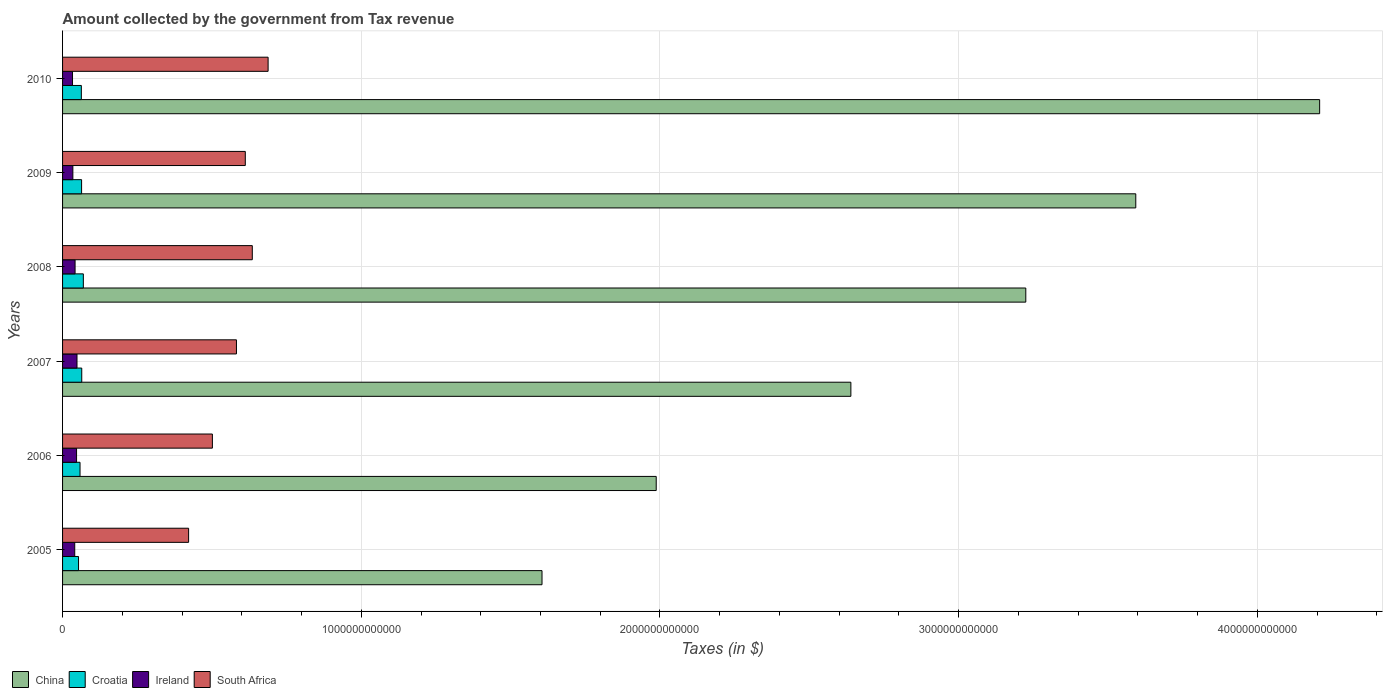Are the number of bars on each tick of the Y-axis equal?
Provide a succinct answer. Yes. What is the amount collected by the government from tax revenue in Ireland in 2010?
Offer a terse response. 3.33e+1. Across all years, what is the maximum amount collected by the government from tax revenue in South Africa?
Provide a succinct answer. 6.88e+11. Across all years, what is the minimum amount collected by the government from tax revenue in Ireland?
Your answer should be compact. 3.33e+1. In which year was the amount collected by the government from tax revenue in South Africa minimum?
Offer a terse response. 2005. What is the total amount collected by the government from tax revenue in China in the graph?
Offer a terse response. 1.73e+13. What is the difference between the amount collected by the government from tax revenue in South Africa in 2005 and that in 2010?
Provide a short and direct response. -2.66e+11. What is the difference between the amount collected by the government from tax revenue in China in 2009 and the amount collected by the government from tax revenue in Ireland in 2007?
Your answer should be very brief. 3.54e+12. What is the average amount collected by the government from tax revenue in China per year?
Keep it short and to the point. 2.88e+12. In the year 2005, what is the difference between the amount collected by the government from tax revenue in China and amount collected by the government from tax revenue in South Africa?
Your response must be concise. 1.18e+12. In how many years, is the amount collected by the government from tax revenue in South Africa greater than 4000000000000 $?
Ensure brevity in your answer.  0. What is the ratio of the amount collected by the government from tax revenue in Croatia in 2006 to that in 2010?
Your answer should be very brief. 0.93. Is the difference between the amount collected by the government from tax revenue in China in 2006 and 2008 greater than the difference between the amount collected by the government from tax revenue in South Africa in 2006 and 2008?
Provide a succinct answer. No. What is the difference between the highest and the second highest amount collected by the government from tax revenue in China?
Provide a short and direct response. 6.16e+11. What is the difference between the highest and the lowest amount collected by the government from tax revenue in Croatia?
Offer a terse response. 1.61e+1. In how many years, is the amount collected by the government from tax revenue in South Africa greater than the average amount collected by the government from tax revenue in South Africa taken over all years?
Provide a succinct answer. 4. Is the sum of the amount collected by the government from tax revenue in South Africa in 2008 and 2010 greater than the maximum amount collected by the government from tax revenue in China across all years?
Give a very brief answer. No. What does the 3rd bar from the bottom in 2007 represents?
Offer a very short reply. Ireland. How many bars are there?
Give a very brief answer. 24. What is the difference between two consecutive major ticks on the X-axis?
Keep it short and to the point. 1.00e+12. Does the graph contain any zero values?
Provide a succinct answer. No. Does the graph contain grids?
Your answer should be compact. Yes. Where does the legend appear in the graph?
Ensure brevity in your answer.  Bottom left. How many legend labels are there?
Your response must be concise. 4. How are the legend labels stacked?
Your answer should be compact. Horizontal. What is the title of the graph?
Your response must be concise. Amount collected by the government from Tax revenue. What is the label or title of the X-axis?
Your answer should be very brief. Taxes (in $). What is the label or title of the Y-axis?
Give a very brief answer. Years. What is the Taxes (in $) in China in 2005?
Offer a very short reply. 1.61e+12. What is the Taxes (in $) of Croatia in 2005?
Provide a short and direct response. 5.34e+1. What is the Taxes (in $) in Ireland in 2005?
Offer a terse response. 4.07e+1. What is the Taxes (in $) of South Africa in 2005?
Your answer should be compact. 4.22e+11. What is the Taxes (in $) of China in 2006?
Make the answer very short. 1.99e+12. What is the Taxes (in $) of Croatia in 2006?
Your response must be concise. 5.85e+1. What is the Taxes (in $) of Ireland in 2006?
Ensure brevity in your answer.  4.69e+1. What is the Taxes (in $) of South Africa in 2006?
Ensure brevity in your answer.  5.02e+11. What is the Taxes (in $) in China in 2007?
Provide a succinct answer. 2.64e+12. What is the Taxes (in $) of Croatia in 2007?
Your response must be concise. 6.42e+1. What is the Taxes (in $) in Ireland in 2007?
Offer a very short reply. 4.83e+1. What is the Taxes (in $) in South Africa in 2007?
Your answer should be very brief. 5.82e+11. What is the Taxes (in $) in China in 2008?
Offer a very short reply. 3.22e+12. What is the Taxes (in $) in Croatia in 2008?
Make the answer very short. 6.96e+1. What is the Taxes (in $) in Ireland in 2008?
Your answer should be very brief. 4.19e+1. What is the Taxes (in $) in South Africa in 2008?
Your answer should be very brief. 6.35e+11. What is the Taxes (in $) of China in 2009?
Your response must be concise. 3.59e+12. What is the Taxes (in $) of Croatia in 2009?
Your response must be concise. 6.37e+1. What is the Taxes (in $) in Ireland in 2009?
Offer a terse response. 3.45e+1. What is the Taxes (in $) in South Africa in 2009?
Provide a succinct answer. 6.12e+11. What is the Taxes (in $) in China in 2010?
Your response must be concise. 4.21e+12. What is the Taxes (in $) of Croatia in 2010?
Offer a very short reply. 6.29e+1. What is the Taxes (in $) of Ireland in 2010?
Your answer should be very brief. 3.33e+1. What is the Taxes (in $) in South Africa in 2010?
Your answer should be very brief. 6.88e+11. Across all years, what is the maximum Taxes (in $) of China?
Ensure brevity in your answer.  4.21e+12. Across all years, what is the maximum Taxes (in $) of Croatia?
Give a very brief answer. 6.96e+1. Across all years, what is the maximum Taxes (in $) in Ireland?
Provide a short and direct response. 4.83e+1. Across all years, what is the maximum Taxes (in $) of South Africa?
Keep it short and to the point. 6.88e+11. Across all years, what is the minimum Taxes (in $) in China?
Keep it short and to the point. 1.61e+12. Across all years, what is the minimum Taxes (in $) in Croatia?
Offer a terse response. 5.34e+1. Across all years, what is the minimum Taxes (in $) in Ireland?
Provide a short and direct response. 3.33e+1. Across all years, what is the minimum Taxes (in $) of South Africa?
Your answer should be compact. 4.22e+11. What is the total Taxes (in $) in China in the graph?
Your response must be concise. 1.73e+13. What is the total Taxes (in $) in Croatia in the graph?
Offer a terse response. 3.72e+11. What is the total Taxes (in $) in Ireland in the graph?
Offer a very short reply. 2.46e+11. What is the total Taxes (in $) in South Africa in the graph?
Give a very brief answer. 3.44e+12. What is the difference between the Taxes (in $) in China in 2005 and that in 2006?
Keep it short and to the point. -3.82e+11. What is the difference between the Taxes (in $) in Croatia in 2005 and that in 2006?
Make the answer very short. -5.02e+09. What is the difference between the Taxes (in $) in Ireland in 2005 and that in 2006?
Give a very brief answer. -6.11e+09. What is the difference between the Taxes (in $) in South Africa in 2005 and that in 2006?
Keep it short and to the point. -7.96e+1. What is the difference between the Taxes (in $) in China in 2005 and that in 2007?
Your answer should be compact. -1.03e+12. What is the difference between the Taxes (in $) of Croatia in 2005 and that in 2007?
Your answer should be compact. -1.08e+1. What is the difference between the Taxes (in $) of Ireland in 2005 and that in 2007?
Provide a short and direct response. -7.58e+09. What is the difference between the Taxes (in $) in South Africa in 2005 and that in 2007?
Your response must be concise. -1.60e+11. What is the difference between the Taxes (in $) of China in 2005 and that in 2008?
Ensure brevity in your answer.  -1.62e+12. What is the difference between the Taxes (in $) of Croatia in 2005 and that in 2008?
Make the answer very short. -1.61e+1. What is the difference between the Taxes (in $) of Ireland in 2005 and that in 2008?
Make the answer very short. -1.15e+09. What is the difference between the Taxes (in $) in South Africa in 2005 and that in 2008?
Offer a very short reply. -2.13e+11. What is the difference between the Taxes (in $) of China in 2005 and that in 2009?
Provide a short and direct response. -1.99e+12. What is the difference between the Taxes (in $) of Croatia in 2005 and that in 2009?
Give a very brief answer. -1.02e+1. What is the difference between the Taxes (in $) of Ireland in 2005 and that in 2009?
Make the answer very short. 6.29e+09. What is the difference between the Taxes (in $) of South Africa in 2005 and that in 2009?
Your response must be concise. -1.90e+11. What is the difference between the Taxes (in $) in China in 2005 and that in 2010?
Ensure brevity in your answer.  -2.60e+12. What is the difference between the Taxes (in $) of Croatia in 2005 and that in 2010?
Keep it short and to the point. -9.41e+09. What is the difference between the Taxes (in $) of Ireland in 2005 and that in 2010?
Offer a terse response. 7.42e+09. What is the difference between the Taxes (in $) of South Africa in 2005 and that in 2010?
Make the answer very short. -2.66e+11. What is the difference between the Taxes (in $) in China in 2006 and that in 2007?
Offer a very short reply. -6.52e+11. What is the difference between the Taxes (in $) of Croatia in 2006 and that in 2007?
Your answer should be compact. -5.77e+09. What is the difference between the Taxes (in $) of Ireland in 2006 and that in 2007?
Your answer should be very brief. -1.47e+09. What is the difference between the Taxes (in $) in South Africa in 2006 and that in 2007?
Ensure brevity in your answer.  -8.05e+1. What is the difference between the Taxes (in $) of China in 2006 and that in 2008?
Ensure brevity in your answer.  -1.24e+12. What is the difference between the Taxes (in $) of Croatia in 2006 and that in 2008?
Provide a short and direct response. -1.11e+1. What is the difference between the Taxes (in $) of Ireland in 2006 and that in 2008?
Your response must be concise. 4.96e+09. What is the difference between the Taxes (in $) in South Africa in 2006 and that in 2008?
Your response must be concise. -1.34e+11. What is the difference between the Taxes (in $) of China in 2006 and that in 2009?
Make the answer very short. -1.61e+12. What is the difference between the Taxes (in $) in Croatia in 2006 and that in 2009?
Provide a succinct answer. -5.21e+09. What is the difference between the Taxes (in $) in Ireland in 2006 and that in 2009?
Give a very brief answer. 1.24e+1. What is the difference between the Taxes (in $) in South Africa in 2006 and that in 2009?
Make the answer very short. -1.10e+11. What is the difference between the Taxes (in $) in China in 2006 and that in 2010?
Give a very brief answer. -2.22e+12. What is the difference between the Taxes (in $) in Croatia in 2006 and that in 2010?
Your response must be concise. -4.39e+09. What is the difference between the Taxes (in $) in Ireland in 2006 and that in 2010?
Provide a succinct answer. 1.35e+1. What is the difference between the Taxes (in $) of South Africa in 2006 and that in 2010?
Your response must be concise. -1.87e+11. What is the difference between the Taxes (in $) in China in 2007 and that in 2008?
Provide a succinct answer. -5.86e+11. What is the difference between the Taxes (in $) in Croatia in 2007 and that in 2008?
Your answer should be very brief. -5.34e+09. What is the difference between the Taxes (in $) of Ireland in 2007 and that in 2008?
Your answer should be very brief. 6.43e+09. What is the difference between the Taxes (in $) in South Africa in 2007 and that in 2008?
Keep it short and to the point. -5.31e+1. What is the difference between the Taxes (in $) in China in 2007 and that in 2009?
Your response must be concise. -9.54e+11. What is the difference between the Taxes (in $) in Croatia in 2007 and that in 2009?
Provide a succinct answer. 5.56e+08. What is the difference between the Taxes (in $) in Ireland in 2007 and that in 2009?
Give a very brief answer. 1.39e+1. What is the difference between the Taxes (in $) in South Africa in 2007 and that in 2009?
Offer a terse response. -2.97e+1. What is the difference between the Taxes (in $) in China in 2007 and that in 2010?
Give a very brief answer. -1.57e+12. What is the difference between the Taxes (in $) of Croatia in 2007 and that in 2010?
Provide a short and direct response. 1.38e+09. What is the difference between the Taxes (in $) in Ireland in 2007 and that in 2010?
Keep it short and to the point. 1.50e+1. What is the difference between the Taxes (in $) of South Africa in 2007 and that in 2010?
Give a very brief answer. -1.06e+11. What is the difference between the Taxes (in $) of China in 2008 and that in 2009?
Provide a short and direct response. -3.68e+11. What is the difference between the Taxes (in $) of Croatia in 2008 and that in 2009?
Keep it short and to the point. 5.89e+09. What is the difference between the Taxes (in $) in Ireland in 2008 and that in 2009?
Your answer should be compact. 7.44e+09. What is the difference between the Taxes (in $) in South Africa in 2008 and that in 2009?
Give a very brief answer. 2.34e+1. What is the difference between the Taxes (in $) of China in 2008 and that in 2010?
Offer a terse response. -9.84e+11. What is the difference between the Taxes (in $) in Croatia in 2008 and that in 2010?
Your answer should be compact. 6.72e+09. What is the difference between the Taxes (in $) of Ireland in 2008 and that in 2010?
Your answer should be compact. 8.56e+09. What is the difference between the Taxes (in $) of South Africa in 2008 and that in 2010?
Ensure brevity in your answer.  -5.29e+1. What is the difference between the Taxes (in $) in China in 2009 and that in 2010?
Give a very brief answer. -6.16e+11. What is the difference between the Taxes (in $) of Croatia in 2009 and that in 2010?
Provide a succinct answer. 8.22e+08. What is the difference between the Taxes (in $) in Ireland in 2009 and that in 2010?
Make the answer very short. 1.13e+09. What is the difference between the Taxes (in $) in South Africa in 2009 and that in 2010?
Ensure brevity in your answer.  -7.63e+1. What is the difference between the Taxes (in $) of China in 2005 and the Taxes (in $) of Croatia in 2006?
Your answer should be compact. 1.55e+12. What is the difference between the Taxes (in $) of China in 2005 and the Taxes (in $) of Ireland in 2006?
Your answer should be very brief. 1.56e+12. What is the difference between the Taxes (in $) in China in 2005 and the Taxes (in $) in South Africa in 2006?
Give a very brief answer. 1.10e+12. What is the difference between the Taxes (in $) of Croatia in 2005 and the Taxes (in $) of Ireland in 2006?
Provide a succinct answer. 6.60e+09. What is the difference between the Taxes (in $) in Croatia in 2005 and the Taxes (in $) in South Africa in 2006?
Provide a short and direct response. -4.48e+11. What is the difference between the Taxes (in $) of Ireland in 2005 and the Taxes (in $) of South Africa in 2006?
Your response must be concise. -4.61e+11. What is the difference between the Taxes (in $) in China in 2005 and the Taxes (in $) in Croatia in 2007?
Your response must be concise. 1.54e+12. What is the difference between the Taxes (in $) of China in 2005 and the Taxes (in $) of Ireland in 2007?
Provide a succinct answer. 1.56e+12. What is the difference between the Taxes (in $) of China in 2005 and the Taxes (in $) of South Africa in 2007?
Give a very brief answer. 1.02e+12. What is the difference between the Taxes (in $) of Croatia in 2005 and the Taxes (in $) of Ireland in 2007?
Give a very brief answer. 5.13e+09. What is the difference between the Taxes (in $) of Croatia in 2005 and the Taxes (in $) of South Africa in 2007?
Your response must be concise. -5.29e+11. What is the difference between the Taxes (in $) in Ireland in 2005 and the Taxes (in $) in South Africa in 2007?
Provide a succinct answer. -5.41e+11. What is the difference between the Taxes (in $) in China in 2005 and the Taxes (in $) in Croatia in 2008?
Keep it short and to the point. 1.54e+12. What is the difference between the Taxes (in $) in China in 2005 and the Taxes (in $) in Ireland in 2008?
Provide a succinct answer. 1.56e+12. What is the difference between the Taxes (in $) of China in 2005 and the Taxes (in $) of South Africa in 2008?
Give a very brief answer. 9.70e+11. What is the difference between the Taxes (in $) of Croatia in 2005 and the Taxes (in $) of Ireland in 2008?
Offer a terse response. 1.16e+1. What is the difference between the Taxes (in $) of Croatia in 2005 and the Taxes (in $) of South Africa in 2008?
Provide a short and direct response. -5.82e+11. What is the difference between the Taxes (in $) of Ireland in 2005 and the Taxes (in $) of South Africa in 2008?
Your answer should be very brief. -5.94e+11. What is the difference between the Taxes (in $) in China in 2005 and the Taxes (in $) in Croatia in 2009?
Your answer should be compact. 1.54e+12. What is the difference between the Taxes (in $) in China in 2005 and the Taxes (in $) in Ireland in 2009?
Keep it short and to the point. 1.57e+12. What is the difference between the Taxes (in $) in China in 2005 and the Taxes (in $) in South Africa in 2009?
Offer a terse response. 9.93e+11. What is the difference between the Taxes (in $) in Croatia in 2005 and the Taxes (in $) in Ireland in 2009?
Your answer should be very brief. 1.90e+1. What is the difference between the Taxes (in $) of Croatia in 2005 and the Taxes (in $) of South Africa in 2009?
Keep it short and to the point. -5.58e+11. What is the difference between the Taxes (in $) in Ireland in 2005 and the Taxes (in $) in South Africa in 2009?
Offer a very short reply. -5.71e+11. What is the difference between the Taxes (in $) in China in 2005 and the Taxes (in $) in Croatia in 2010?
Offer a very short reply. 1.54e+12. What is the difference between the Taxes (in $) in China in 2005 and the Taxes (in $) in Ireland in 2010?
Offer a very short reply. 1.57e+12. What is the difference between the Taxes (in $) in China in 2005 and the Taxes (in $) in South Africa in 2010?
Provide a short and direct response. 9.17e+11. What is the difference between the Taxes (in $) of Croatia in 2005 and the Taxes (in $) of Ireland in 2010?
Make the answer very short. 2.01e+1. What is the difference between the Taxes (in $) in Croatia in 2005 and the Taxes (in $) in South Africa in 2010?
Ensure brevity in your answer.  -6.35e+11. What is the difference between the Taxes (in $) of Ireland in 2005 and the Taxes (in $) of South Africa in 2010?
Give a very brief answer. -6.47e+11. What is the difference between the Taxes (in $) in China in 2006 and the Taxes (in $) in Croatia in 2007?
Your answer should be compact. 1.92e+12. What is the difference between the Taxes (in $) of China in 2006 and the Taxes (in $) of Ireland in 2007?
Provide a short and direct response. 1.94e+12. What is the difference between the Taxes (in $) in China in 2006 and the Taxes (in $) in South Africa in 2007?
Ensure brevity in your answer.  1.41e+12. What is the difference between the Taxes (in $) of Croatia in 2006 and the Taxes (in $) of Ireland in 2007?
Make the answer very short. 1.02e+1. What is the difference between the Taxes (in $) of Croatia in 2006 and the Taxes (in $) of South Africa in 2007?
Offer a very short reply. -5.24e+11. What is the difference between the Taxes (in $) in Ireland in 2006 and the Taxes (in $) in South Africa in 2007?
Make the answer very short. -5.35e+11. What is the difference between the Taxes (in $) of China in 2006 and the Taxes (in $) of Croatia in 2008?
Provide a short and direct response. 1.92e+12. What is the difference between the Taxes (in $) in China in 2006 and the Taxes (in $) in Ireland in 2008?
Offer a terse response. 1.95e+12. What is the difference between the Taxes (in $) in China in 2006 and the Taxes (in $) in South Africa in 2008?
Offer a terse response. 1.35e+12. What is the difference between the Taxes (in $) of Croatia in 2006 and the Taxes (in $) of Ireland in 2008?
Make the answer very short. 1.66e+1. What is the difference between the Taxes (in $) of Croatia in 2006 and the Taxes (in $) of South Africa in 2008?
Your answer should be compact. -5.77e+11. What is the difference between the Taxes (in $) of Ireland in 2006 and the Taxes (in $) of South Africa in 2008?
Keep it short and to the point. -5.88e+11. What is the difference between the Taxes (in $) of China in 2006 and the Taxes (in $) of Croatia in 2009?
Provide a short and direct response. 1.92e+12. What is the difference between the Taxes (in $) in China in 2006 and the Taxes (in $) in Ireland in 2009?
Provide a short and direct response. 1.95e+12. What is the difference between the Taxes (in $) of China in 2006 and the Taxes (in $) of South Africa in 2009?
Offer a terse response. 1.38e+12. What is the difference between the Taxes (in $) of Croatia in 2006 and the Taxes (in $) of Ireland in 2009?
Ensure brevity in your answer.  2.40e+1. What is the difference between the Taxes (in $) in Croatia in 2006 and the Taxes (in $) in South Africa in 2009?
Your answer should be compact. -5.53e+11. What is the difference between the Taxes (in $) of Ireland in 2006 and the Taxes (in $) of South Africa in 2009?
Offer a terse response. -5.65e+11. What is the difference between the Taxes (in $) of China in 2006 and the Taxes (in $) of Croatia in 2010?
Your answer should be compact. 1.92e+12. What is the difference between the Taxes (in $) in China in 2006 and the Taxes (in $) in Ireland in 2010?
Give a very brief answer. 1.95e+12. What is the difference between the Taxes (in $) of China in 2006 and the Taxes (in $) of South Africa in 2010?
Provide a short and direct response. 1.30e+12. What is the difference between the Taxes (in $) in Croatia in 2006 and the Taxes (in $) in Ireland in 2010?
Ensure brevity in your answer.  2.51e+1. What is the difference between the Taxes (in $) in Croatia in 2006 and the Taxes (in $) in South Africa in 2010?
Your answer should be very brief. -6.30e+11. What is the difference between the Taxes (in $) of Ireland in 2006 and the Taxes (in $) of South Africa in 2010?
Offer a terse response. -6.41e+11. What is the difference between the Taxes (in $) in China in 2007 and the Taxes (in $) in Croatia in 2008?
Your response must be concise. 2.57e+12. What is the difference between the Taxes (in $) of China in 2007 and the Taxes (in $) of Ireland in 2008?
Provide a succinct answer. 2.60e+12. What is the difference between the Taxes (in $) in China in 2007 and the Taxes (in $) in South Africa in 2008?
Offer a terse response. 2.00e+12. What is the difference between the Taxes (in $) in Croatia in 2007 and the Taxes (in $) in Ireland in 2008?
Your answer should be compact. 2.23e+1. What is the difference between the Taxes (in $) of Croatia in 2007 and the Taxes (in $) of South Africa in 2008?
Offer a terse response. -5.71e+11. What is the difference between the Taxes (in $) in Ireland in 2007 and the Taxes (in $) in South Africa in 2008?
Provide a short and direct response. -5.87e+11. What is the difference between the Taxes (in $) in China in 2007 and the Taxes (in $) in Croatia in 2009?
Keep it short and to the point. 2.58e+12. What is the difference between the Taxes (in $) in China in 2007 and the Taxes (in $) in Ireland in 2009?
Provide a short and direct response. 2.60e+12. What is the difference between the Taxes (in $) in China in 2007 and the Taxes (in $) in South Africa in 2009?
Your answer should be very brief. 2.03e+12. What is the difference between the Taxes (in $) in Croatia in 2007 and the Taxes (in $) in Ireland in 2009?
Keep it short and to the point. 2.98e+1. What is the difference between the Taxes (in $) in Croatia in 2007 and the Taxes (in $) in South Africa in 2009?
Keep it short and to the point. -5.48e+11. What is the difference between the Taxes (in $) of Ireland in 2007 and the Taxes (in $) of South Africa in 2009?
Give a very brief answer. -5.63e+11. What is the difference between the Taxes (in $) in China in 2007 and the Taxes (in $) in Croatia in 2010?
Offer a very short reply. 2.58e+12. What is the difference between the Taxes (in $) in China in 2007 and the Taxes (in $) in Ireland in 2010?
Your answer should be compact. 2.61e+12. What is the difference between the Taxes (in $) of China in 2007 and the Taxes (in $) of South Africa in 2010?
Offer a terse response. 1.95e+12. What is the difference between the Taxes (in $) of Croatia in 2007 and the Taxes (in $) of Ireland in 2010?
Offer a terse response. 3.09e+1. What is the difference between the Taxes (in $) in Croatia in 2007 and the Taxes (in $) in South Africa in 2010?
Ensure brevity in your answer.  -6.24e+11. What is the difference between the Taxes (in $) in Ireland in 2007 and the Taxes (in $) in South Africa in 2010?
Provide a short and direct response. -6.40e+11. What is the difference between the Taxes (in $) of China in 2008 and the Taxes (in $) of Croatia in 2009?
Your answer should be compact. 3.16e+12. What is the difference between the Taxes (in $) of China in 2008 and the Taxes (in $) of Ireland in 2009?
Your response must be concise. 3.19e+12. What is the difference between the Taxes (in $) of China in 2008 and the Taxes (in $) of South Africa in 2009?
Make the answer very short. 2.61e+12. What is the difference between the Taxes (in $) in Croatia in 2008 and the Taxes (in $) in Ireland in 2009?
Give a very brief answer. 3.51e+1. What is the difference between the Taxes (in $) in Croatia in 2008 and the Taxes (in $) in South Africa in 2009?
Provide a succinct answer. -5.42e+11. What is the difference between the Taxes (in $) of Ireland in 2008 and the Taxes (in $) of South Africa in 2009?
Ensure brevity in your answer.  -5.70e+11. What is the difference between the Taxes (in $) in China in 2008 and the Taxes (in $) in Croatia in 2010?
Ensure brevity in your answer.  3.16e+12. What is the difference between the Taxes (in $) in China in 2008 and the Taxes (in $) in Ireland in 2010?
Your response must be concise. 3.19e+12. What is the difference between the Taxes (in $) in China in 2008 and the Taxes (in $) in South Africa in 2010?
Your response must be concise. 2.54e+12. What is the difference between the Taxes (in $) of Croatia in 2008 and the Taxes (in $) of Ireland in 2010?
Provide a succinct answer. 3.62e+1. What is the difference between the Taxes (in $) in Croatia in 2008 and the Taxes (in $) in South Africa in 2010?
Provide a short and direct response. -6.19e+11. What is the difference between the Taxes (in $) of Ireland in 2008 and the Taxes (in $) of South Africa in 2010?
Provide a succinct answer. -6.46e+11. What is the difference between the Taxes (in $) of China in 2009 and the Taxes (in $) of Croatia in 2010?
Keep it short and to the point. 3.53e+12. What is the difference between the Taxes (in $) in China in 2009 and the Taxes (in $) in Ireland in 2010?
Your response must be concise. 3.56e+12. What is the difference between the Taxes (in $) in China in 2009 and the Taxes (in $) in South Africa in 2010?
Ensure brevity in your answer.  2.90e+12. What is the difference between the Taxes (in $) in Croatia in 2009 and the Taxes (in $) in Ireland in 2010?
Make the answer very short. 3.04e+1. What is the difference between the Taxes (in $) in Croatia in 2009 and the Taxes (in $) in South Africa in 2010?
Offer a very short reply. -6.24e+11. What is the difference between the Taxes (in $) in Ireland in 2009 and the Taxes (in $) in South Africa in 2010?
Your response must be concise. -6.54e+11. What is the average Taxes (in $) in China per year?
Make the answer very short. 2.88e+12. What is the average Taxes (in $) in Croatia per year?
Give a very brief answer. 6.20e+1. What is the average Taxes (in $) in Ireland per year?
Give a very brief answer. 4.09e+1. What is the average Taxes (in $) of South Africa per year?
Your response must be concise. 5.73e+11. In the year 2005, what is the difference between the Taxes (in $) in China and Taxes (in $) in Croatia?
Your answer should be compact. 1.55e+12. In the year 2005, what is the difference between the Taxes (in $) in China and Taxes (in $) in Ireland?
Your answer should be very brief. 1.56e+12. In the year 2005, what is the difference between the Taxes (in $) of China and Taxes (in $) of South Africa?
Your answer should be compact. 1.18e+12. In the year 2005, what is the difference between the Taxes (in $) of Croatia and Taxes (in $) of Ireland?
Provide a succinct answer. 1.27e+1. In the year 2005, what is the difference between the Taxes (in $) in Croatia and Taxes (in $) in South Africa?
Ensure brevity in your answer.  -3.69e+11. In the year 2005, what is the difference between the Taxes (in $) in Ireland and Taxes (in $) in South Africa?
Give a very brief answer. -3.81e+11. In the year 2006, what is the difference between the Taxes (in $) in China and Taxes (in $) in Croatia?
Ensure brevity in your answer.  1.93e+12. In the year 2006, what is the difference between the Taxes (in $) of China and Taxes (in $) of Ireland?
Ensure brevity in your answer.  1.94e+12. In the year 2006, what is the difference between the Taxes (in $) in China and Taxes (in $) in South Africa?
Your answer should be very brief. 1.49e+12. In the year 2006, what is the difference between the Taxes (in $) in Croatia and Taxes (in $) in Ireland?
Give a very brief answer. 1.16e+1. In the year 2006, what is the difference between the Taxes (in $) in Croatia and Taxes (in $) in South Africa?
Your answer should be compact. -4.43e+11. In the year 2006, what is the difference between the Taxes (in $) in Ireland and Taxes (in $) in South Africa?
Provide a succinct answer. -4.55e+11. In the year 2007, what is the difference between the Taxes (in $) in China and Taxes (in $) in Croatia?
Your response must be concise. 2.57e+12. In the year 2007, what is the difference between the Taxes (in $) in China and Taxes (in $) in Ireland?
Provide a succinct answer. 2.59e+12. In the year 2007, what is the difference between the Taxes (in $) in China and Taxes (in $) in South Africa?
Provide a succinct answer. 2.06e+12. In the year 2007, what is the difference between the Taxes (in $) in Croatia and Taxes (in $) in Ireland?
Offer a terse response. 1.59e+1. In the year 2007, what is the difference between the Taxes (in $) of Croatia and Taxes (in $) of South Africa?
Make the answer very short. -5.18e+11. In the year 2007, what is the difference between the Taxes (in $) in Ireland and Taxes (in $) in South Africa?
Your answer should be compact. -5.34e+11. In the year 2008, what is the difference between the Taxes (in $) of China and Taxes (in $) of Croatia?
Provide a short and direct response. 3.16e+12. In the year 2008, what is the difference between the Taxes (in $) in China and Taxes (in $) in Ireland?
Your answer should be very brief. 3.18e+12. In the year 2008, what is the difference between the Taxes (in $) of China and Taxes (in $) of South Africa?
Offer a very short reply. 2.59e+12. In the year 2008, what is the difference between the Taxes (in $) in Croatia and Taxes (in $) in Ireland?
Provide a short and direct response. 2.77e+1. In the year 2008, what is the difference between the Taxes (in $) in Croatia and Taxes (in $) in South Africa?
Offer a terse response. -5.66e+11. In the year 2008, what is the difference between the Taxes (in $) in Ireland and Taxes (in $) in South Africa?
Provide a succinct answer. -5.93e+11. In the year 2009, what is the difference between the Taxes (in $) in China and Taxes (in $) in Croatia?
Offer a terse response. 3.53e+12. In the year 2009, what is the difference between the Taxes (in $) of China and Taxes (in $) of Ireland?
Ensure brevity in your answer.  3.56e+12. In the year 2009, what is the difference between the Taxes (in $) in China and Taxes (in $) in South Africa?
Provide a succinct answer. 2.98e+12. In the year 2009, what is the difference between the Taxes (in $) in Croatia and Taxes (in $) in Ireland?
Provide a short and direct response. 2.92e+1. In the year 2009, what is the difference between the Taxes (in $) of Croatia and Taxes (in $) of South Africa?
Your answer should be compact. -5.48e+11. In the year 2009, what is the difference between the Taxes (in $) of Ireland and Taxes (in $) of South Africa?
Ensure brevity in your answer.  -5.77e+11. In the year 2010, what is the difference between the Taxes (in $) in China and Taxes (in $) in Croatia?
Provide a short and direct response. 4.15e+12. In the year 2010, what is the difference between the Taxes (in $) in China and Taxes (in $) in Ireland?
Your answer should be very brief. 4.18e+12. In the year 2010, what is the difference between the Taxes (in $) of China and Taxes (in $) of South Africa?
Your response must be concise. 3.52e+12. In the year 2010, what is the difference between the Taxes (in $) of Croatia and Taxes (in $) of Ireland?
Make the answer very short. 2.95e+1. In the year 2010, what is the difference between the Taxes (in $) in Croatia and Taxes (in $) in South Africa?
Offer a terse response. -6.25e+11. In the year 2010, what is the difference between the Taxes (in $) in Ireland and Taxes (in $) in South Africa?
Provide a short and direct response. -6.55e+11. What is the ratio of the Taxes (in $) in China in 2005 to that in 2006?
Provide a short and direct response. 0.81. What is the ratio of the Taxes (in $) in Croatia in 2005 to that in 2006?
Ensure brevity in your answer.  0.91. What is the ratio of the Taxes (in $) in Ireland in 2005 to that in 2006?
Ensure brevity in your answer.  0.87. What is the ratio of the Taxes (in $) in South Africa in 2005 to that in 2006?
Ensure brevity in your answer.  0.84. What is the ratio of the Taxes (in $) in China in 2005 to that in 2007?
Offer a terse response. 0.61. What is the ratio of the Taxes (in $) of Croatia in 2005 to that in 2007?
Your answer should be compact. 0.83. What is the ratio of the Taxes (in $) in Ireland in 2005 to that in 2007?
Your answer should be compact. 0.84. What is the ratio of the Taxes (in $) in South Africa in 2005 to that in 2007?
Provide a succinct answer. 0.72. What is the ratio of the Taxes (in $) in China in 2005 to that in 2008?
Your answer should be very brief. 0.5. What is the ratio of the Taxes (in $) in Croatia in 2005 to that in 2008?
Offer a very short reply. 0.77. What is the ratio of the Taxes (in $) of Ireland in 2005 to that in 2008?
Give a very brief answer. 0.97. What is the ratio of the Taxes (in $) in South Africa in 2005 to that in 2008?
Ensure brevity in your answer.  0.66. What is the ratio of the Taxes (in $) of China in 2005 to that in 2009?
Your answer should be very brief. 0.45. What is the ratio of the Taxes (in $) of Croatia in 2005 to that in 2009?
Give a very brief answer. 0.84. What is the ratio of the Taxes (in $) in Ireland in 2005 to that in 2009?
Provide a succinct answer. 1.18. What is the ratio of the Taxes (in $) in South Africa in 2005 to that in 2009?
Offer a terse response. 0.69. What is the ratio of the Taxes (in $) in China in 2005 to that in 2010?
Make the answer very short. 0.38. What is the ratio of the Taxes (in $) in Croatia in 2005 to that in 2010?
Ensure brevity in your answer.  0.85. What is the ratio of the Taxes (in $) of Ireland in 2005 to that in 2010?
Keep it short and to the point. 1.22. What is the ratio of the Taxes (in $) of South Africa in 2005 to that in 2010?
Your response must be concise. 0.61. What is the ratio of the Taxes (in $) of China in 2006 to that in 2007?
Give a very brief answer. 0.75. What is the ratio of the Taxes (in $) in Croatia in 2006 to that in 2007?
Give a very brief answer. 0.91. What is the ratio of the Taxes (in $) in Ireland in 2006 to that in 2007?
Your response must be concise. 0.97. What is the ratio of the Taxes (in $) in South Africa in 2006 to that in 2007?
Ensure brevity in your answer.  0.86. What is the ratio of the Taxes (in $) in China in 2006 to that in 2008?
Your response must be concise. 0.62. What is the ratio of the Taxes (in $) in Croatia in 2006 to that in 2008?
Offer a very short reply. 0.84. What is the ratio of the Taxes (in $) of Ireland in 2006 to that in 2008?
Give a very brief answer. 1.12. What is the ratio of the Taxes (in $) in South Africa in 2006 to that in 2008?
Ensure brevity in your answer.  0.79. What is the ratio of the Taxes (in $) in China in 2006 to that in 2009?
Make the answer very short. 0.55. What is the ratio of the Taxes (in $) of Croatia in 2006 to that in 2009?
Your answer should be compact. 0.92. What is the ratio of the Taxes (in $) of Ireland in 2006 to that in 2009?
Give a very brief answer. 1.36. What is the ratio of the Taxes (in $) of South Africa in 2006 to that in 2009?
Give a very brief answer. 0.82. What is the ratio of the Taxes (in $) of China in 2006 to that in 2010?
Your answer should be very brief. 0.47. What is the ratio of the Taxes (in $) of Croatia in 2006 to that in 2010?
Offer a terse response. 0.93. What is the ratio of the Taxes (in $) in Ireland in 2006 to that in 2010?
Your response must be concise. 1.41. What is the ratio of the Taxes (in $) of South Africa in 2006 to that in 2010?
Offer a terse response. 0.73. What is the ratio of the Taxes (in $) in China in 2007 to that in 2008?
Offer a terse response. 0.82. What is the ratio of the Taxes (in $) of Croatia in 2007 to that in 2008?
Offer a very short reply. 0.92. What is the ratio of the Taxes (in $) of Ireland in 2007 to that in 2008?
Ensure brevity in your answer.  1.15. What is the ratio of the Taxes (in $) in South Africa in 2007 to that in 2008?
Give a very brief answer. 0.92. What is the ratio of the Taxes (in $) in China in 2007 to that in 2009?
Make the answer very short. 0.73. What is the ratio of the Taxes (in $) in Croatia in 2007 to that in 2009?
Keep it short and to the point. 1.01. What is the ratio of the Taxes (in $) in Ireland in 2007 to that in 2009?
Your answer should be very brief. 1.4. What is the ratio of the Taxes (in $) of South Africa in 2007 to that in 2009?
Give a very brief answer. 0.95. What is the ratio of the Taxes (in $) in China in 2007 to that in 2010?
Keep it short and to the point. 0.63. What is the ratio of the Taxes (in $) of Croatia in 2007 to that in 2010?
Offer a terse response. 1.02. What is the ratio of the Taxes (in $) of Ireland in 2007 to that in 2010?
Make the answer very short. 1.45. What is the ratio of the Taxes (in $) in South Africa in 2007 to that in 2010?
Give a very brief answer. 0.85. What is the ratio of the Taxes (in $) of China in 2008 to that in 2009?
Provide a succinct answer. 0.9. What is the ratio of the Taxes (in $) of Croatia in 2008 to that in 2009?
Your response must be concise. 1.09. What is the ratio of the Taxes (in $) in Ireland in 2008 to that in 2009?
Your response must be concise. 1.22. What is the ratio of the Taxes (in $) in South Africa in 2008 to that in 2009?
Your answer should be very brief. 1.04. What is the ratio of the Taxes (in $) of China in 2008 to that in 2010?
Offer a very short reply. 0.77. What is the ratio of the Taxes (in $) of Croatia in 2008 to that in 2010?
Provide a succinct answer. 1.11. What is the ratio of the Taxes (in $) in Ireland in 2008 to that in 2010?
Your answer should be very brief. 1.26. What is the ratio of the Taxes (in $) in China in 2009 to that in 2010?
Offer a terse response. 0.85. What is the ratio of the Taxes (in $) of Croatia in 2009 to that in 2010?
Ensure brevity in your answer.  1.01. What is the ratio of the Taxes (in $) of Ireland in 2009 to that in 2010?
Offer a terse response. 1.03. What is the ratio of the Taxes (in $) in South Africa in 2009 to that in 2010?
Make the answer very short. 0.89. What is the difference between the highest and the second highest Taxes (in $) of China?
Offer a terse response. 6.16e+11. What is the difference between the highest and the second highest Taxes (in $) of Croatia?
Make the answer very short. 5.34e+09. What is the difference between the highest and the second highest Taxes (in $) of Ireland?
Keep it short and to the point. 1.47e+09. What is the difference between the highest and the second highest Taxes (in $) of South Africa?
Keep it short and to the point. 5.29e+1. What is the difference between the highest and the lowest Taxes (in $) in China?
Offer a very short reply. 2.60e+12. What is the difference between the highest and the lowest Taxes (in $) in Croatia?
Your answer should be compact. 1.61e+1. What is the difference between the highest and the lowest Taxes (in $) in Ireland?
Your response must be concise. 1.50e+1. What is the difference between the highest and the lowest Taxes (in $) of South Africa?
Offer a terse response. 2.66e+11. 